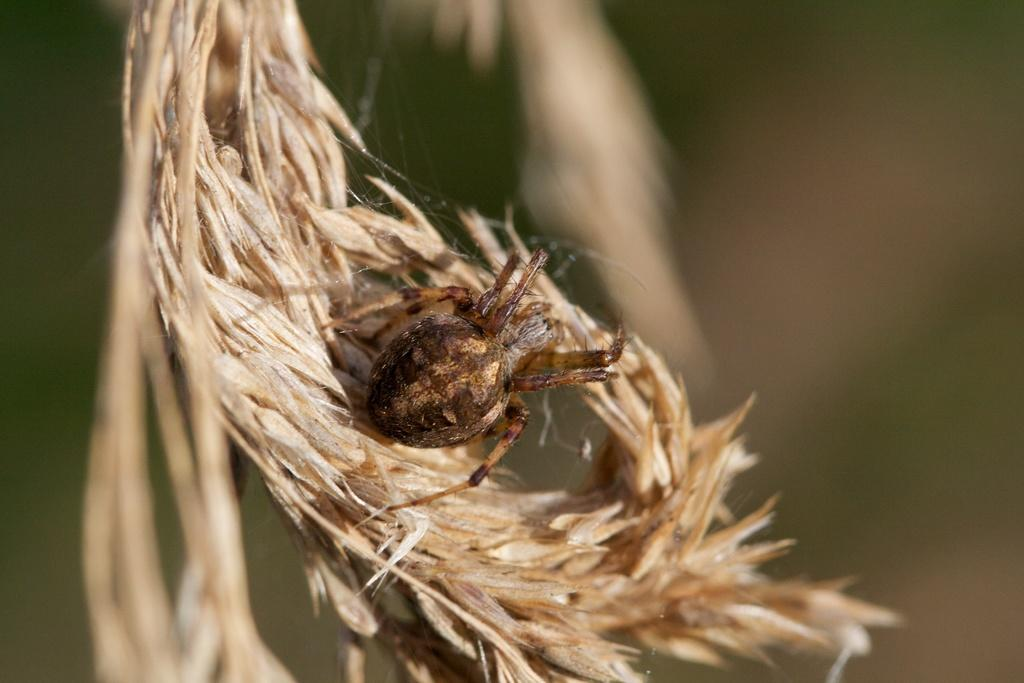What is present in the image? There is a spider in the image. Where is the spider located? The spider is on a plant. What type of alarm is the spider setting off in the image? There is no alarm present in the image, and the spider is not setting off any alarms. How many pies is the spider eating in the image? There are no pies present in the image, and the spider is not eating any pies. 